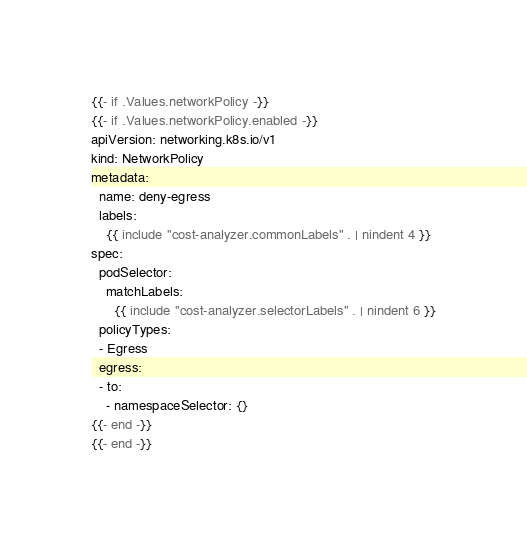Convert code to text. <code><loc_0><loc_0><loc_500><loc_500><_YAML_>{{- if .Values.networkPolicy -}}
{{- if .Values.networkPolicy.enabled -}}
apiVersion: networking.k8s.io/v1
kind: NetworkPolicy
metadata:
  name: deny-egress
  labels:
    {{ include "cost-analyzer.commonLabels" . | nindent 4 }}
spec:
  podSelector:
    matchLabels:
      {{ include "cost-analyzer.selectorLabels" . | nindent 6 }}
  policyTypes:
  - Egress
  egress:
  - to:
    - namespaceSelector: {}
{{- end -}}
{{- end -}}
</code> 